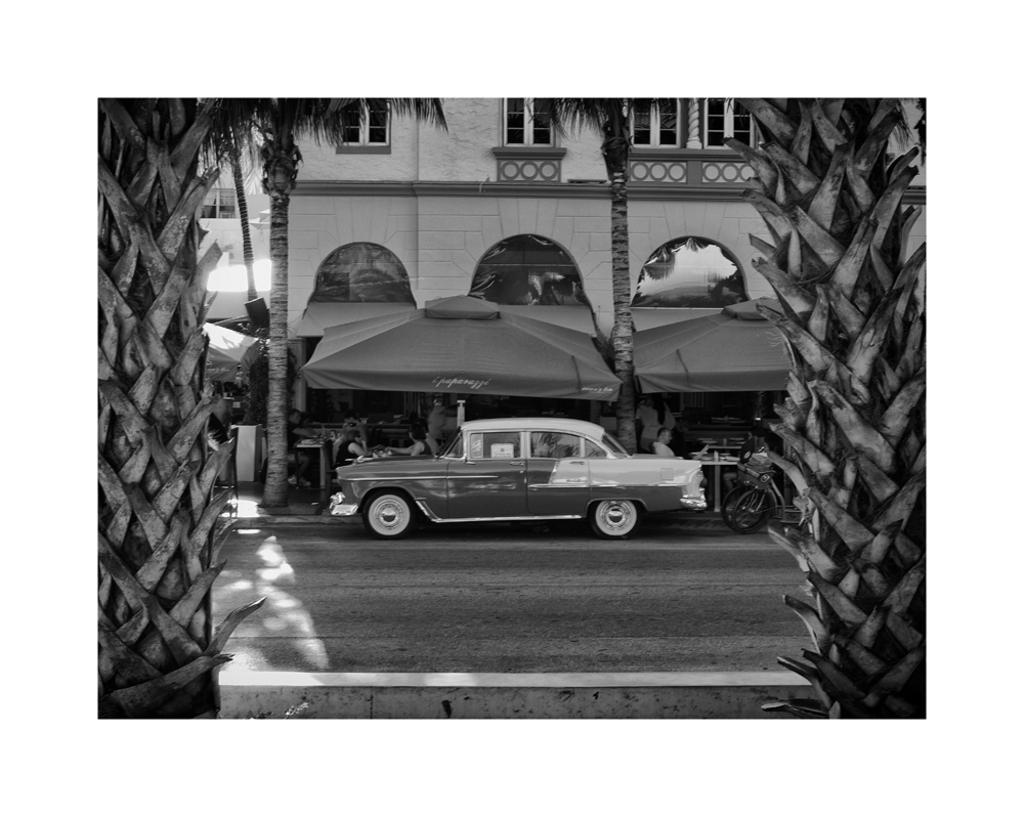What can be seen on the road in the image? There are vehicles on the road in the image. What is visible in the background of the image? There are trees, people, and a building in the background of the image. What is the color scheme of the image? The image is black and white in color. Is there any rain visible in the image? There is no rain visible in the image; it is a black and white image with no indication of weather conditions. What type of treatment is being administered to the trees in the image? There is no treatment being administered to the trees in the image; they are simply visible in the background. 